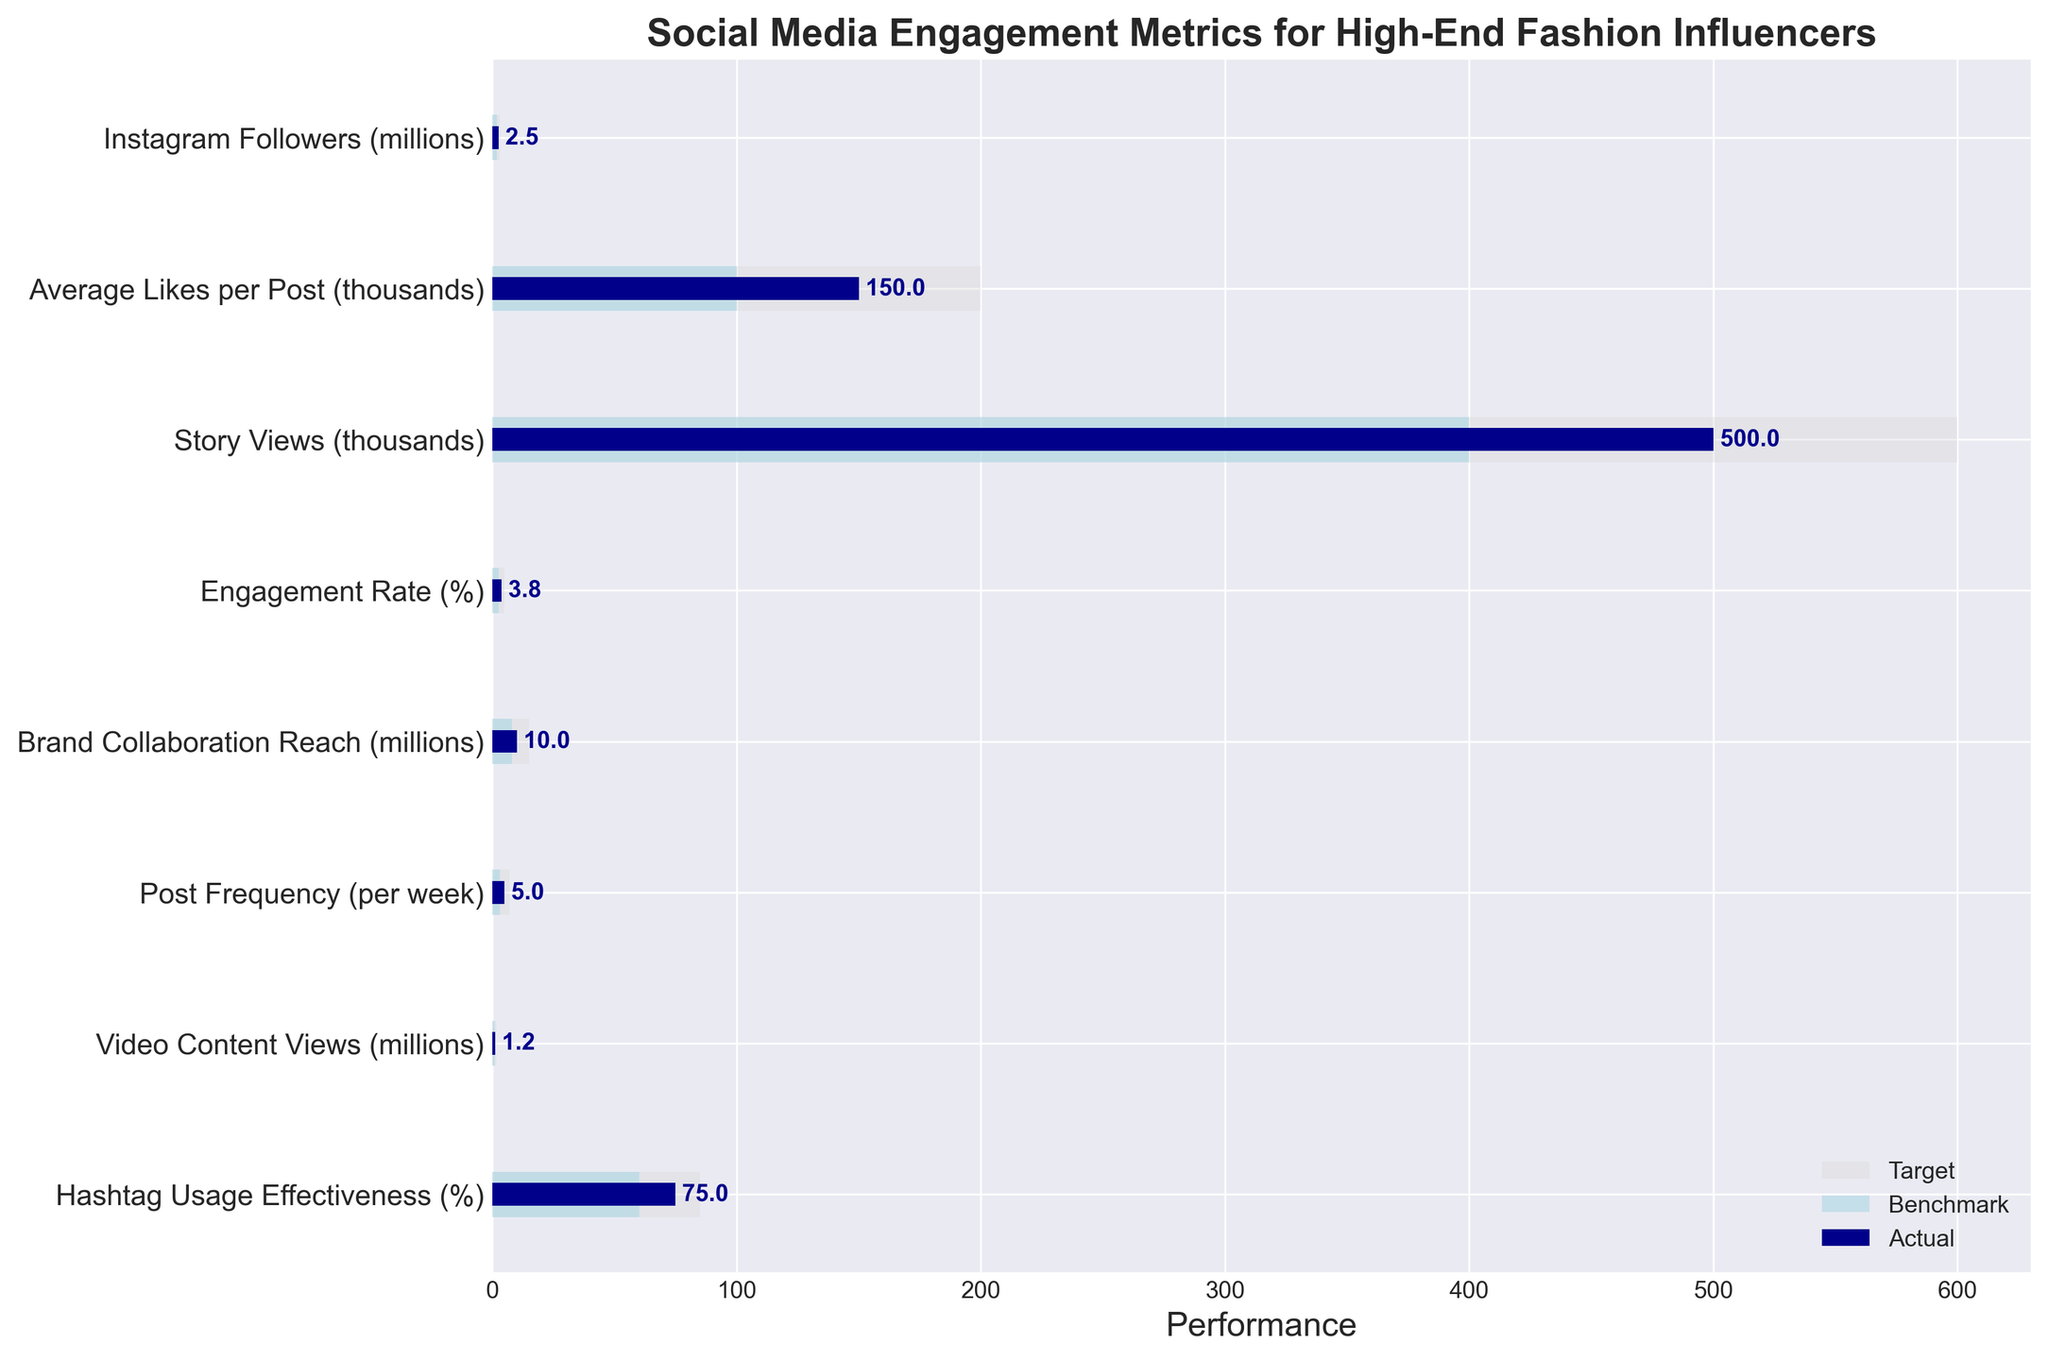How many metrics are displayed in the chart? Count the number of metrics listed on the y-axis. There are eight metrics shown: Instagram Followers, Average Likes per Post, Story Views, Engagement Rate, Brand Collaboration Reach, Post Frequency, Video Content Views, and Hashtag Usage Effectiveness.
Answer: 8 What is the actual value of Instagram Followers? Look at the bullet chart bar corresponding to Instagram Followers on the y-axis; the actual value bar is marked in dark blue. The actual value of Instagram Followers is labeled as 2.5 million.
Answer: 2.5 million Which metric has the highest target value? Compare the target values (light grey bars) for each metric on the chart. Brand Collaboration Reach has the highest target value of 15 million.
Answer: Brand Collaboration Reach How does the Engagement Rate compare to the Benchmark? Look at the Engagement Rate on the y-axis, and compare the height of the light blue (Benchmark) and dark blue (Actual) bars. The actual Engagement Rate (3.8%) is higher than the Benchmark (2.5%).
Answer: Higher Which metrics exceed their respective benchmarks? Compare the dark blue (actual) bars to the light blue (benchmark) bars for each metric. The metrics that exceed their benchmarks are: Instagram Followers, Average Likes per Post, Story Views, Engagement Rate, Brand Collaboration Reach, Video Content Views, and Hashtag Usage Effectiveness.
Answer: 6 metrics Is the Story Views metric closer to the target or the benchmark? Examine the Story Views metric on the y-axis and compare the lengths of the dark blue (actual), light grey (target), and light blue (benchmark) bars. The actual Story Views (500,000) is closer to the target (600,000) than the benchmark (400,000).
Answer: Target By how much does the actual Post Frequency surpass the benchmark? Find the Post Frequency metric on the y-axis and subtract the benchmark value (3 per week) from the actual value (5 per week). The difference is 5 - 3 = 2 per week.
Answer: 2 per week Which metric has the smallest difference between the actual and target values? Compare the differences between the actual (dark blue bars) and target values (light grey bars) for each metric. Instagram Followers have the smallest difference: 3.0 - 2.5 = 0.5 million.
Answer: Instagram Followers What is the total actual engagement rate percentage across all metrics? Add up the actual engagement rate percentages for each metric shown (excluding those without a percentage figure): Engagement Rate (3.8%) and Hashtag Usage Effectiveness (75%). The total is 3.8% + 75% = 78.8%.
Answer: 78.8% How does the Brand Collaboration Reach compare to its target? Assess the Brand Collaboration Reach on the y-axis. Compare the actual value (10 million) with the target value (15 million). The actual Brand Collaboration Reach is 5 million short of its target.
Answer: 5 million short 